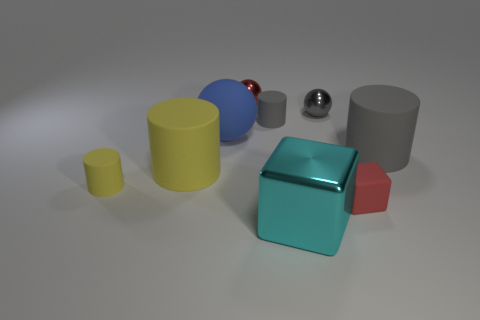What color is the tiny matte cube?
Keep it short and to the point. Red. There is a tiny red block; are there any large rubber things on the left side of it?
Ensure brevity in your answer.  Yes. How many balls are the same color as the tiny cube?
Ensure brevity in your answer.  1. There is a metallic thing that is in front of the rubber cylinder that is to the right of the gray ball; what is its size?
Keep it short and to the point. Large. What is the shape of the big gray thing?
Keep it short and to the point. Cylinder. There is a large gray cylinder behind the tiny matte cube; what is it made of?
Provide a succinct answer. Rubber. What color is the small matte cylinder in front of the sphere in front of the tiny cylinder on the right side of the red ball?
Your answer should be very brief. Yellow. The other metal ball that is the same size as the red metallic sphere is what color?
Provide a succinct answer. Gray. What number of rubber things are big purple balls or cyan cubes?
Ensure brevity in your answer.  0. What is the color of the cube that is the same material as the big ball?
Offer a very short reply. Red. 